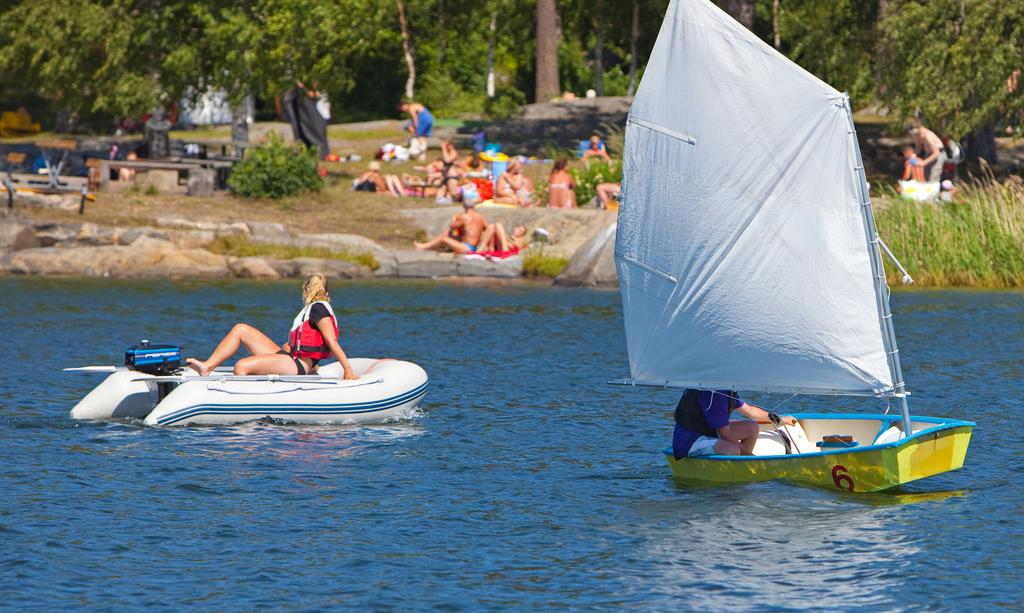What is happening on the water in the image? There are boats on the water in the image. How many people are in the boats? There are two people in the boats. What else can be seen in the image besides the boats and people? There are people on the ground, benches, trees, and plants visible in the background of the image. Are there any giants visible in the image? No, there are no giants present in the image. What type of border can be seen surrounding the image? There is no border visible around the image; it is a photograph or digital image without a frame. 